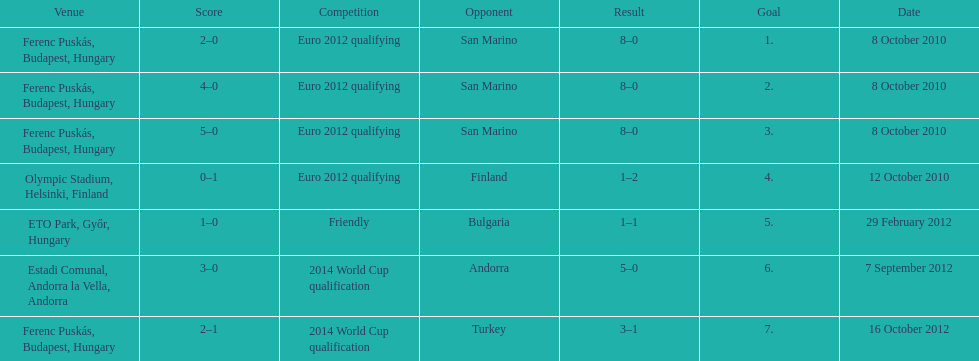In what year was szalai's first international goal? 2010. 